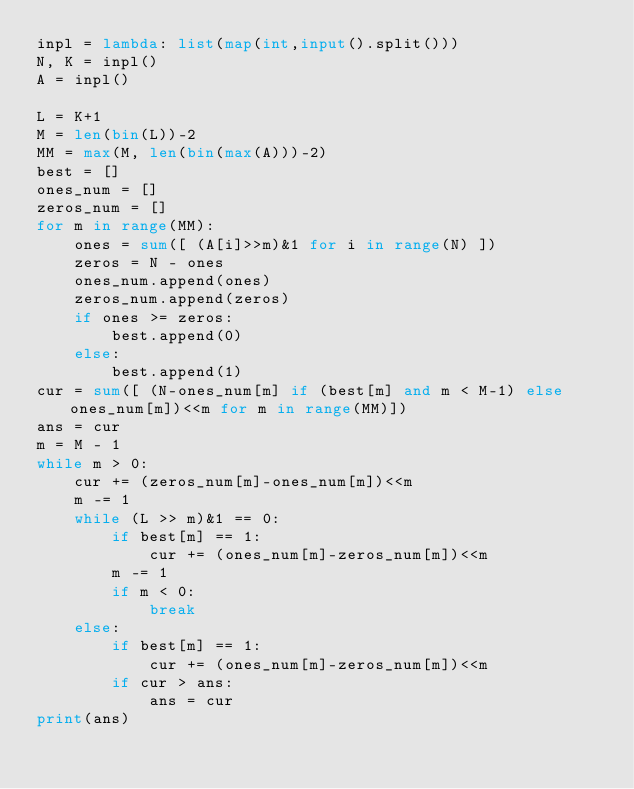Convert code to text. <code><loc_0><loc_0><loc_500><loc_500><_Python_>inpl = lambda: list(map(int,input().split()))
N, K = inpl()
A = inpl()

L = K+1
M = len(bin(L))-2
MM = max(M, len(bin(max(A)))-2)
best = []
ones_num = []
zeros_num = []
for m in range(MM):
    ones = sum([ (A[i]>>m)&1 for i in range(N) ])
    zeros = N - ones
    ones_num.append(ones)
    zeros_num.append(zeros)
    if ones >= zeros:
        best.append(0)
    else:
        best.append(1)
cur = sum([ (N-ones_num[m] if (best[m] and m < M-1) else ones_num[m])<<m for m in range(MM)])
ans = cur
m = M - 1
while m > 0:
    cur += (zeros_num[m]-ones_num[m])<<m
    m -= 1
    while (L >> m)&1 == 0:
        if best[m] == 1:
            cur += (ones_num[m]-zeros_num[m])<<m
        m -= 1
        if m < 0:
            break
    else:
        if best[m] == 1:
            cur += (ones_num[m]-zeros_num[m])<<m
        if cur > ans:
            ans = cur
print(ans)</code> 